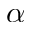<formula> <loc_0><loc_0><loc_500><loc_500>\alpha</formula> 